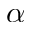<formula> <loc_0><loc_0><loc_500><loc_500>\alpha</formula> 